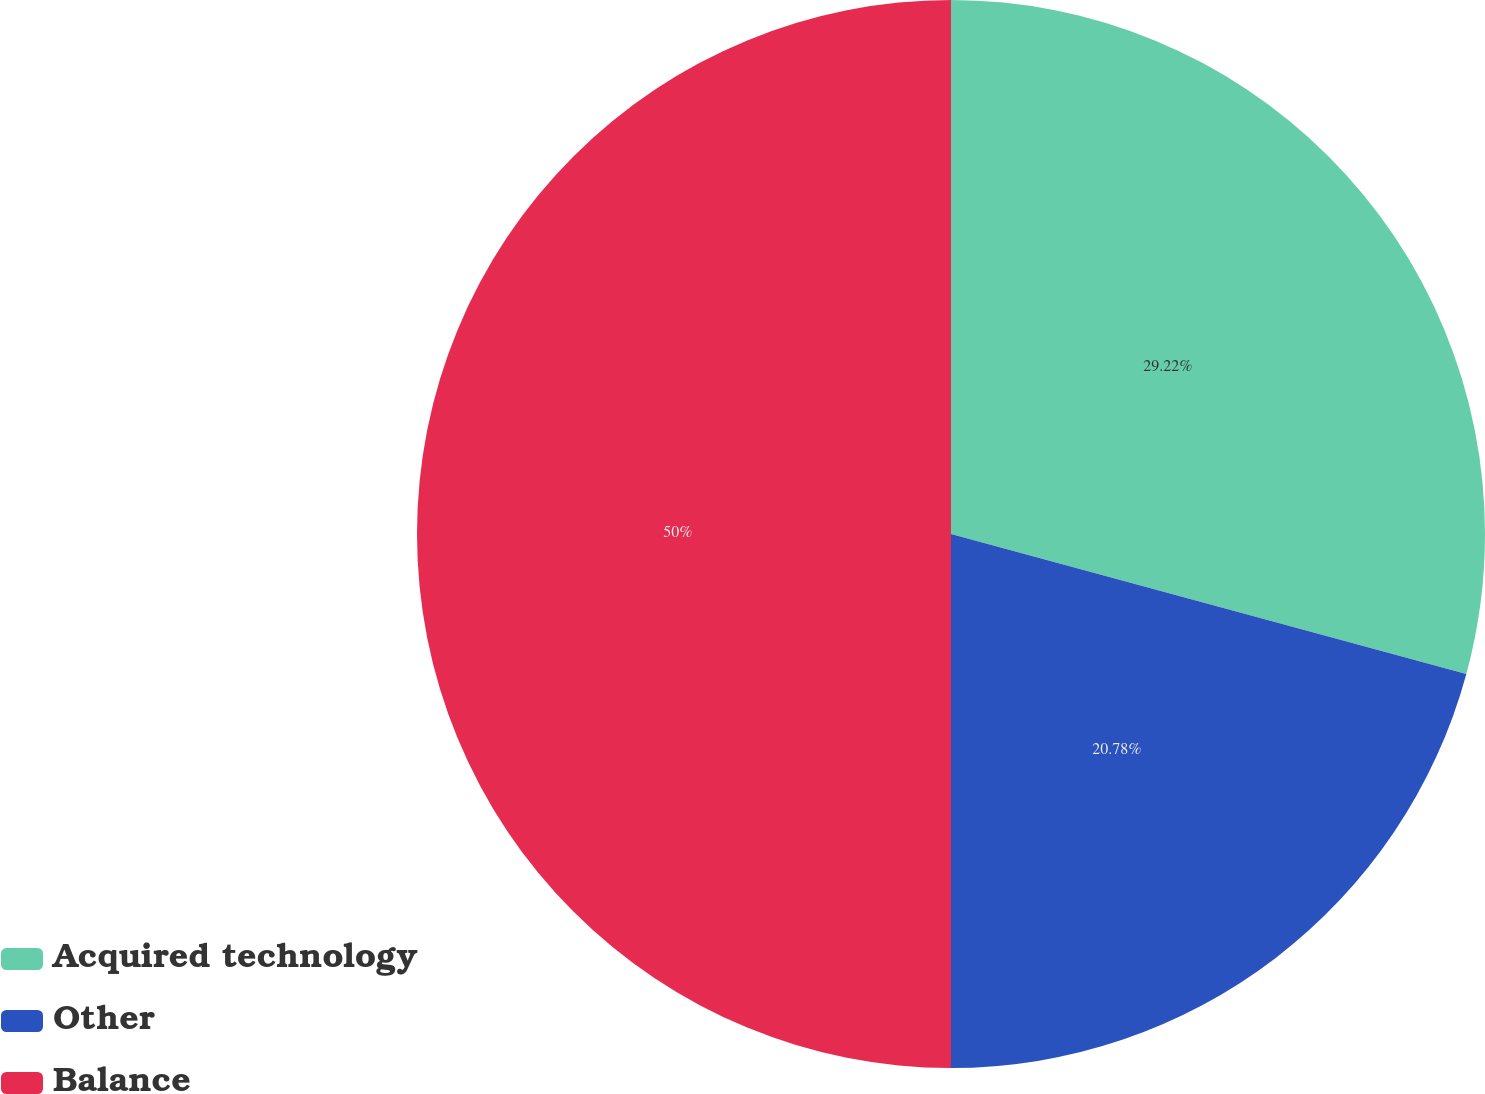Convert chart to OTSL. <chart><loc_0><loc_0><loc_500><loc_500><pie_chart><fcel>Acquired technology<fcel>Other<fcel>Balance<nl><fcel>29.22%<fcel>20.78%<fcel>50.0%<nl></chart> 